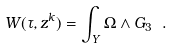<formula> <loc_0><loc_0><loc_500><loc_500>W ( \tau , z ^ { k } ) = \int _ { Y } \Omega \wedge G _ { 3 } \ .</formula> 